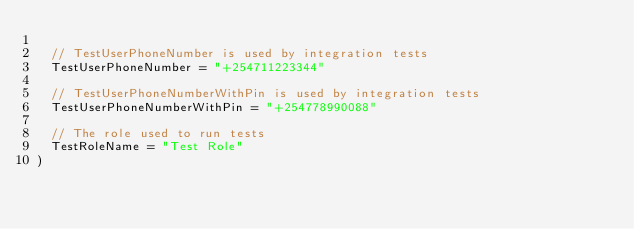<code> <loc_0><loc_0><loc_500><loc_500><_Go_>
	// TestUserPhoneNumber is used by integration tests
	TestUserPhoneNumber = "+254711223344"

	// TestUserPhoneNumberWithPin is used by integration tests
	TestUserPhoneNumberWithPin = "+254778990088"

	// The role used to run tests
	TestRoleName = "Test Role"
)
</code> 